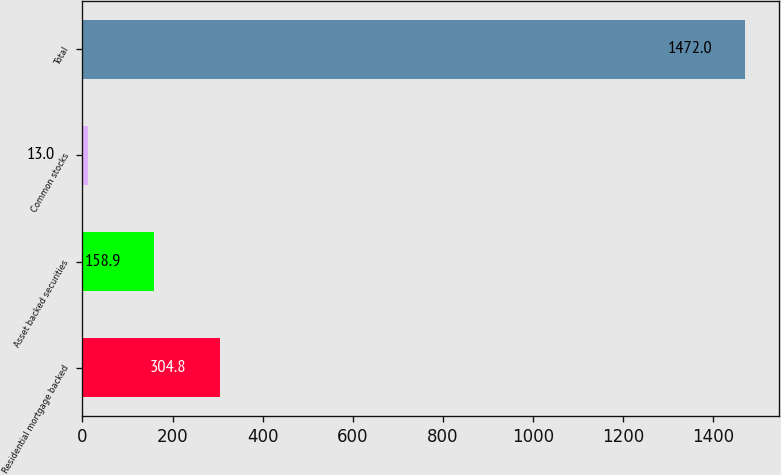Convert chart. <chart><loc_0><loc_0><loc_500><loc_500><bar_chart><fcel>Residential mortgage backed<fcel>Asset backed securities<fcel>Common stocks<fcel>Total<nl><fcel>304.8<fcel>158.9<fcel>13<fcel>1472<nl></chart> 